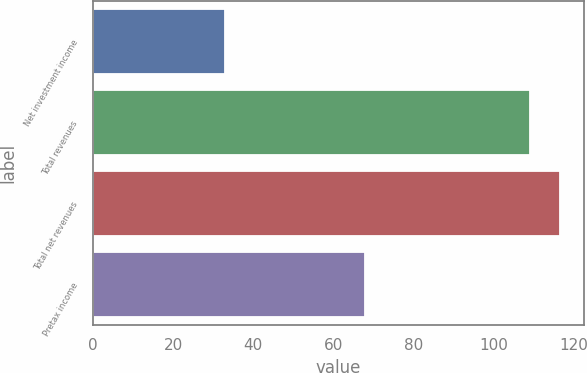<chart> <loc_0><loc_0><loc_500><loc_500><bar_chart><fcel>Net investment income<fcel>Total revenues<fcel>Total net revenues<fcel>Pretax income<nl><fcel>33<fcel>109<fcel>116.6<fcel>68<nl></chart> 